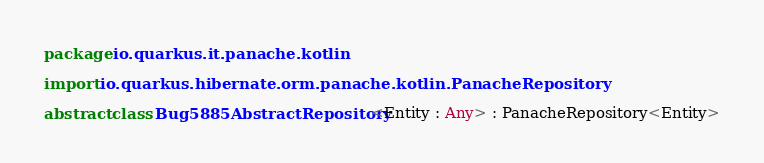Convert code to text. <code><loc_0><loc_0><loc_500><loc_500><_Kotlin_>package io.quarkus.it.panache.kotlin

import io.quarkus.hibernate.orm.panache.kotlin.PanacheRepository

abstract class Bug5885AbstractRepository<Entity : Any> : PanacheRepository<Entity></code> 